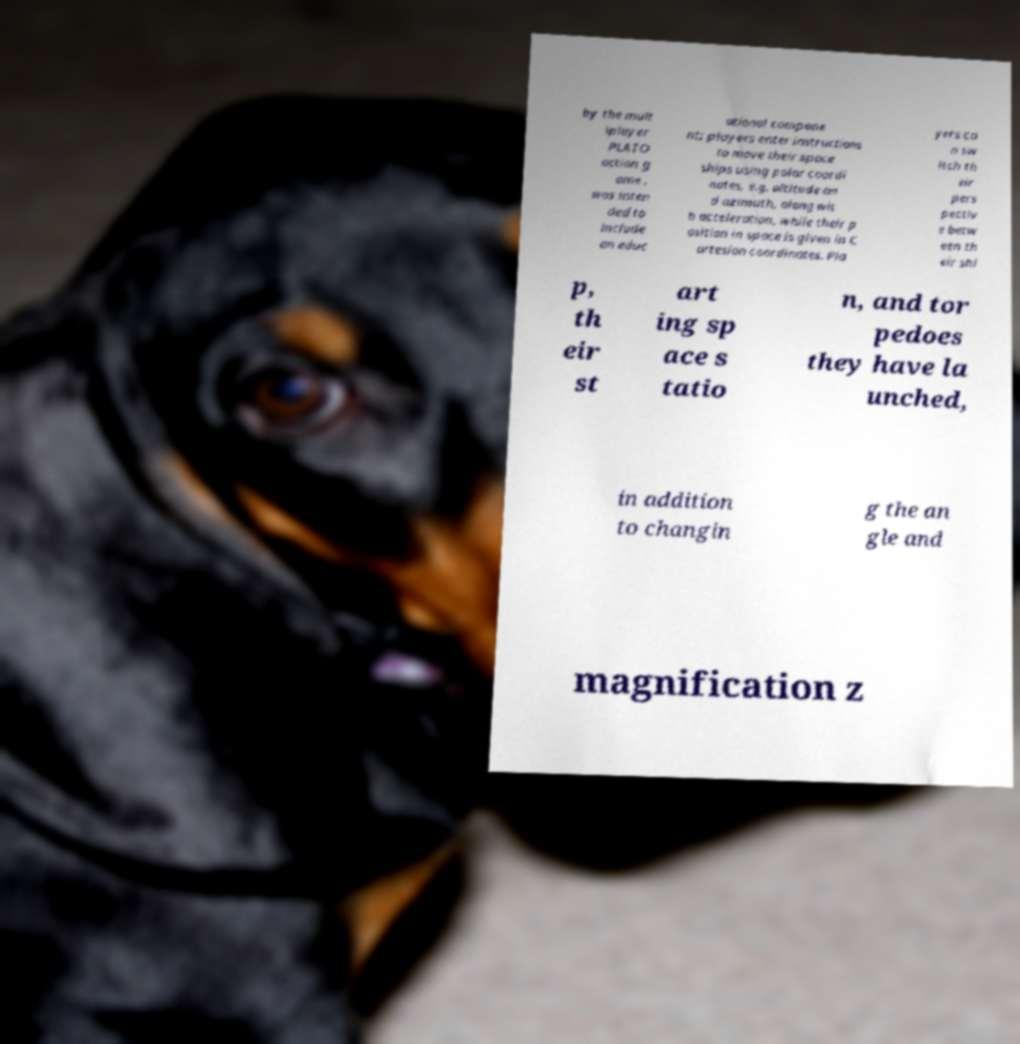What messages or text are displayed in this image? I need them in a readable, typed format. by the mult iplayer PLATO action g ame . was inten ded to include an educ ational compone nt; players enter instructions to move their space ships using polar coordi nates, e.g. altitude an d azimuth, along wit h acceleration, while their p osition in space is given in C artesian coordinates. Pla yers ca n sw itch th eir pers pectiv e betw een th eir shi p, th eir st art ing sp ace s tatio n, and tor pedoes they have la unched, in addition to changin g the an gle and magnification z 